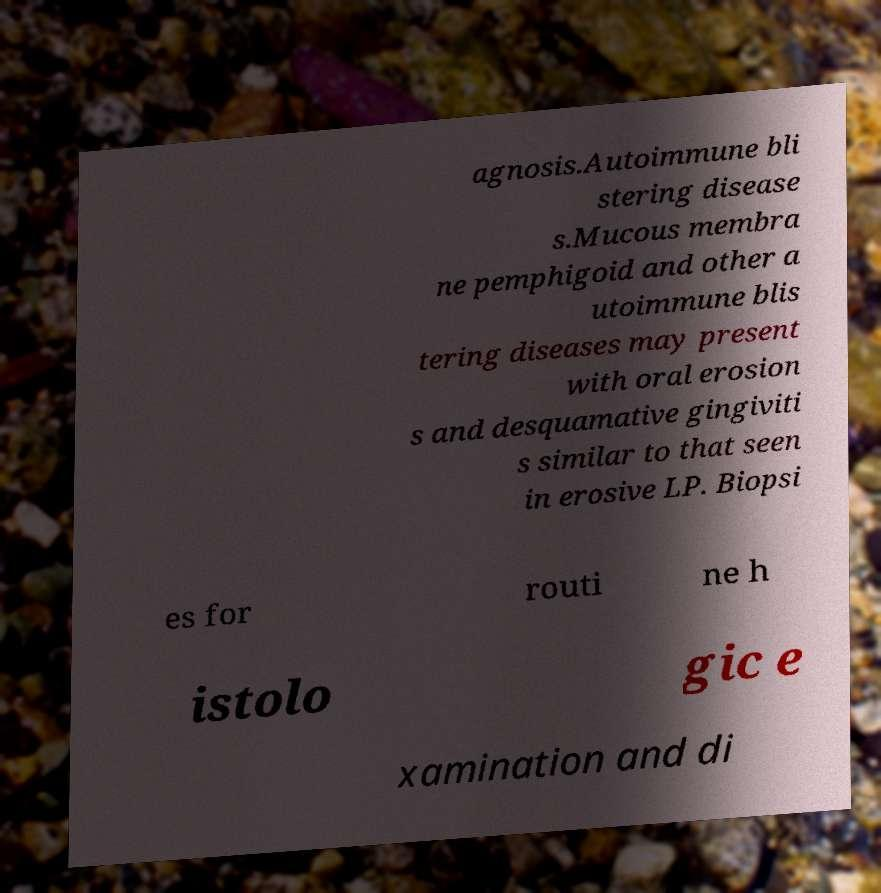Please identify and transcribe the text found in this image. agnosis.Autoimmune bli stering disease s.Mucous membra ne pemphigoid and other a utoimmune blis tering diseases may present with oral erosion s and desquamative gingiviti s similar to that seen in erosive LP. Biopsi es for routi ne h istolo gic e xamination and di 